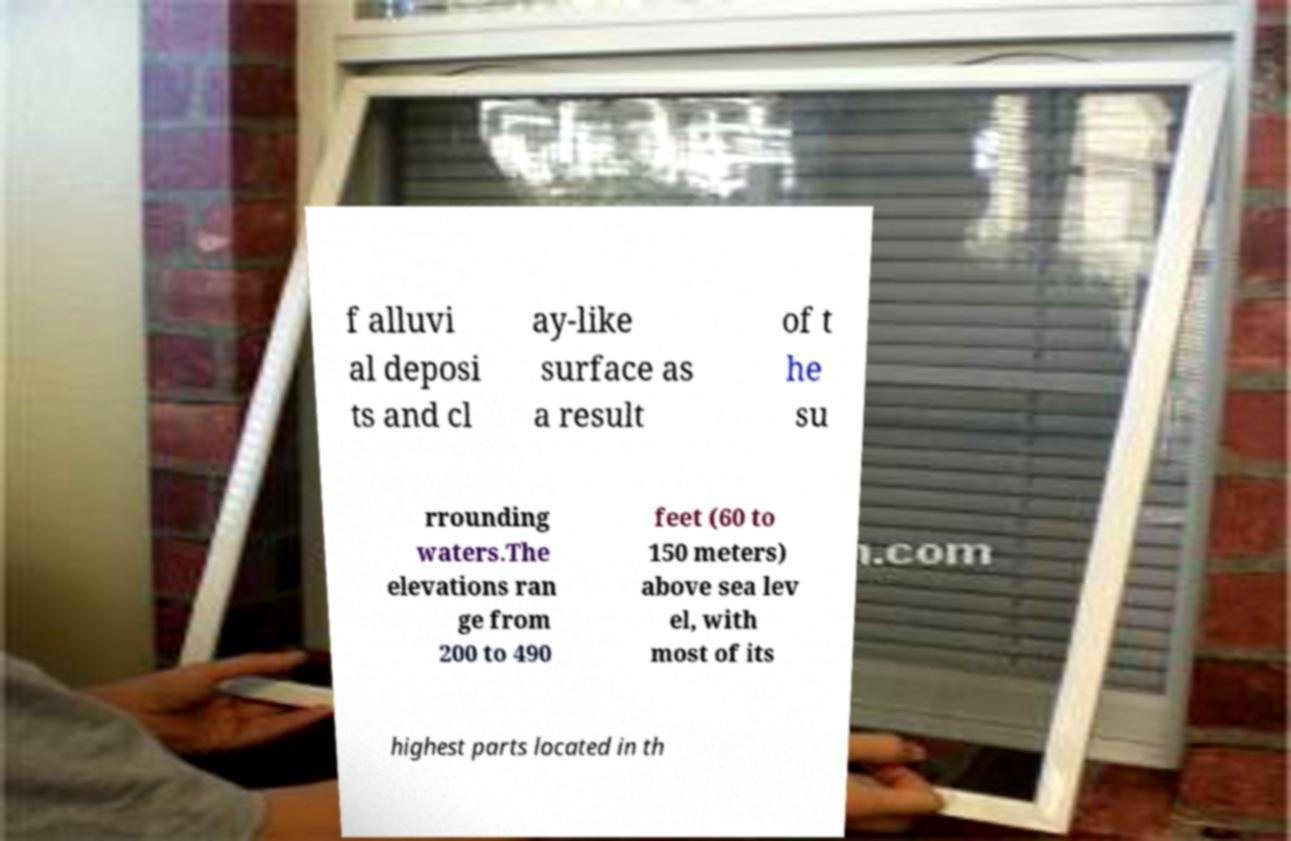Can you read and provide the text displayed in the image?This photo seems to have some interesting text. Can you extract and type it out for me? f alluvi al deposi ts and cl ay-like surface as a result of t he su rrounding waters.The elevations ran ge from 200 to 490 feet (60 to 150 meters) above sea lev el, with most of its highest parts located in th 